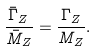<formula> <loc_0><loc_0><loc_500><loc_500>\frac { \bar { \Gamma } _ { Z } } { \bar { M } _ { Z } } = \frac { \Gamma _ { Z } } { M _ { Z } } .</formula> 